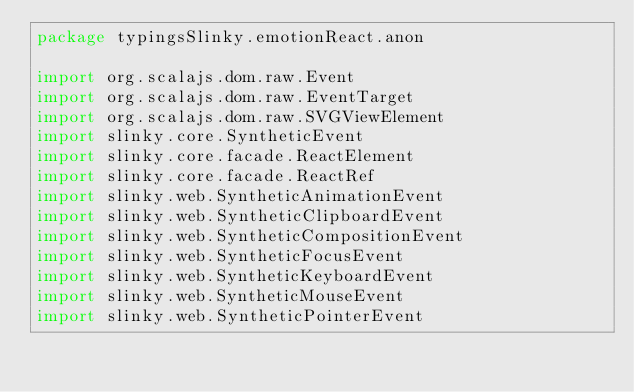Convert code to text. <code><loc_0><loc_0><loc_500><loc_500><_Scala_>package typingsSlinky.emotionReact.anon

import org.scalajs.dom.raw.Event
import org.scalajs.dom.raw.EventTarget
import org.scalajs.dom.raw.SVGViewElement
import slinky.core.SyntheticEvent
import slinky.core.facade.ReactElement
import slinky.core.facade.ReactRef
import slinky.web.SyntheticAnimationEvent
import slinky.web.SyntheticClipboardEvent
import slinky.web.SyntheticCompositionEvent
import slinky.web.SyntheticFocusEvent
import slinky.web.SyntheticKeyboardEvent
import slinky.web.SyntheticMouseEvent
import slinky.web.SyntheticPointerEvent</code> 